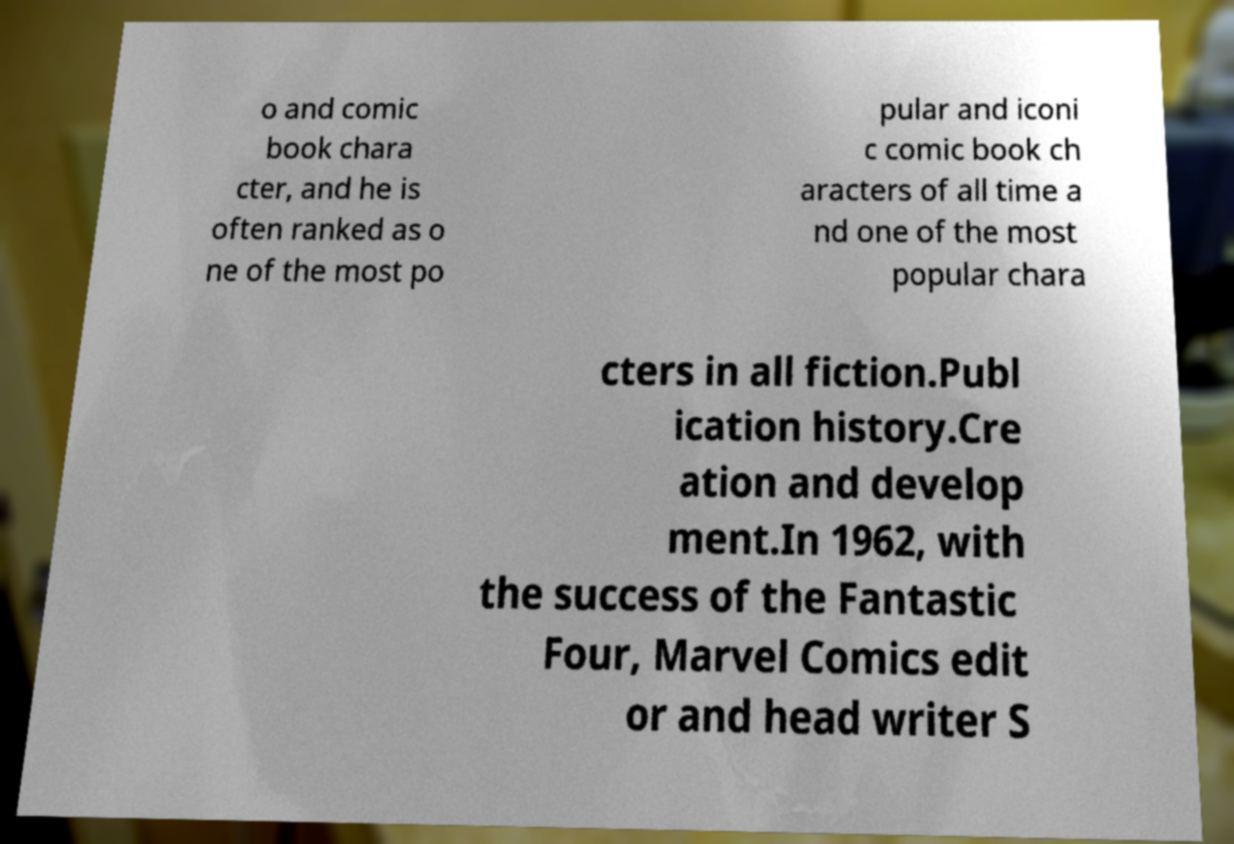There's text embedded in this image that I need extracted. Can you transcribe it verbatim? o and comic book chara cter, and he is often ranked as o ne of the most po pular and iconi c comic book ch aracters of all time a nd one of the most popular chara cters in all fiction.Publ ication history.Cre ation and develop ment.In 1962, with the success of the Fantastic Four, Marvel Comics edit or and head writer S 